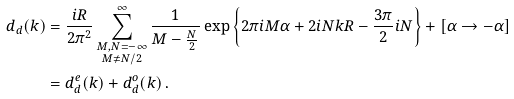<formula> <loc_0><loc_0><loc_500><loc_500>d _ { d } ( k ) & = \frac { i R } { 2 \pi ^ { 2 } } \sum _ { \substack { M , N = - \infty \\ M \neq N / 2 } } ^ { \infty } \frac { 1 } { M - \frac { N } { 2 } } \exp \left \{ 2 \pi i M \alpha + 2 i N k R - \frac { 3 \pi } { 2 } i N \right \} + [ \alpha \rightarrow - \alpha ] \\ & = d _ { d } ^ { e } ( k ) + d _ { d } ^ { o } ( k ) \, .</formula> 